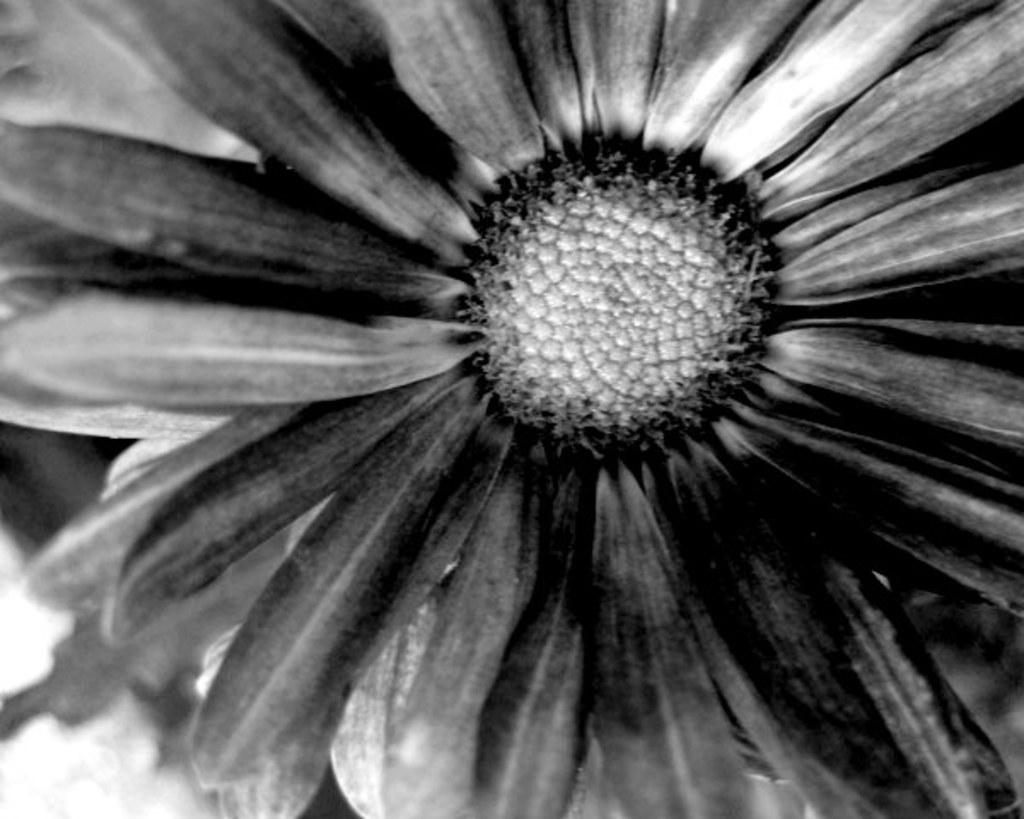What is the color scheme of the image? The image is black and white. What type of object can be seen in the image? There is a flower in the image. How many stars can be seen in the image? There are no stars present in the image, as it is a black and white image featuring a flower. 